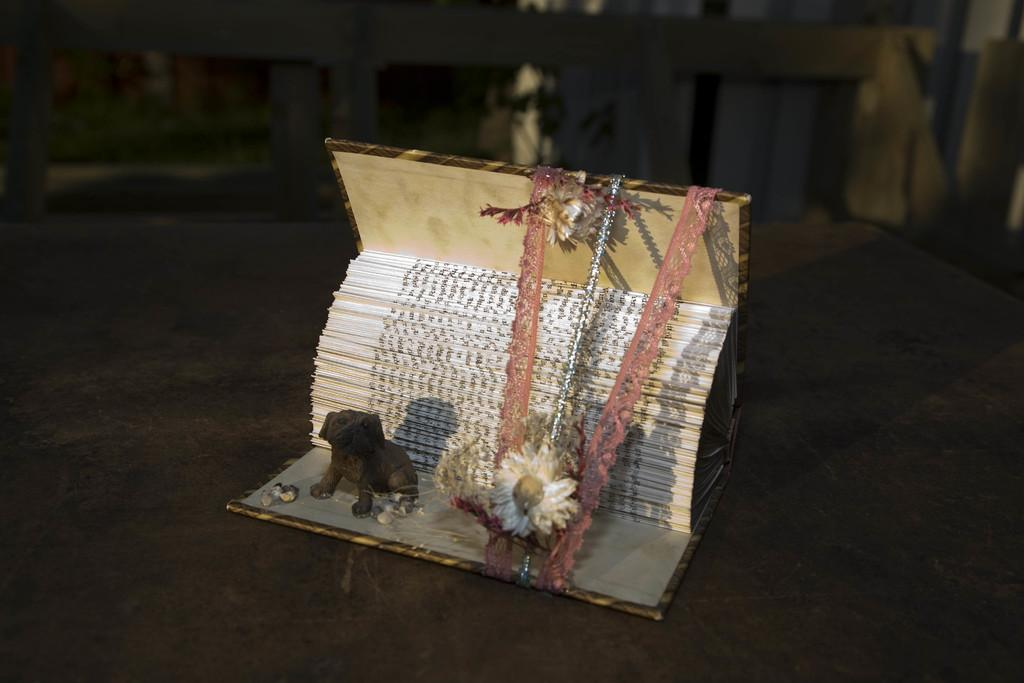What type of toy is in the image? There is a toy in the image, but the specific type is not mentioned. What other living organism is in the image besides the toy? There is a flower in the image. What type of material is used for the cloth pieces in the image? The material of the cloth pieces is not specified in the facts. What is the book about in the image? The content of the book is not mentioned in the facts. On what surface are the objects placed in the image? The objects are on a surface, but the type of surface is not specified. What type of vegetation is visible in the background of the image? There is grass and a plant visible in the background of the image. What other objects can be seen in the background of the image? There are other objects visible in the background of the image, but their specific nature is not mentioned. What type of stone is being used by the army in the image? There is no mention of a stone or an army in the image. How does the toy slip on the surface in the image? The toy does not slip on the surface in the image; it is stationary. 